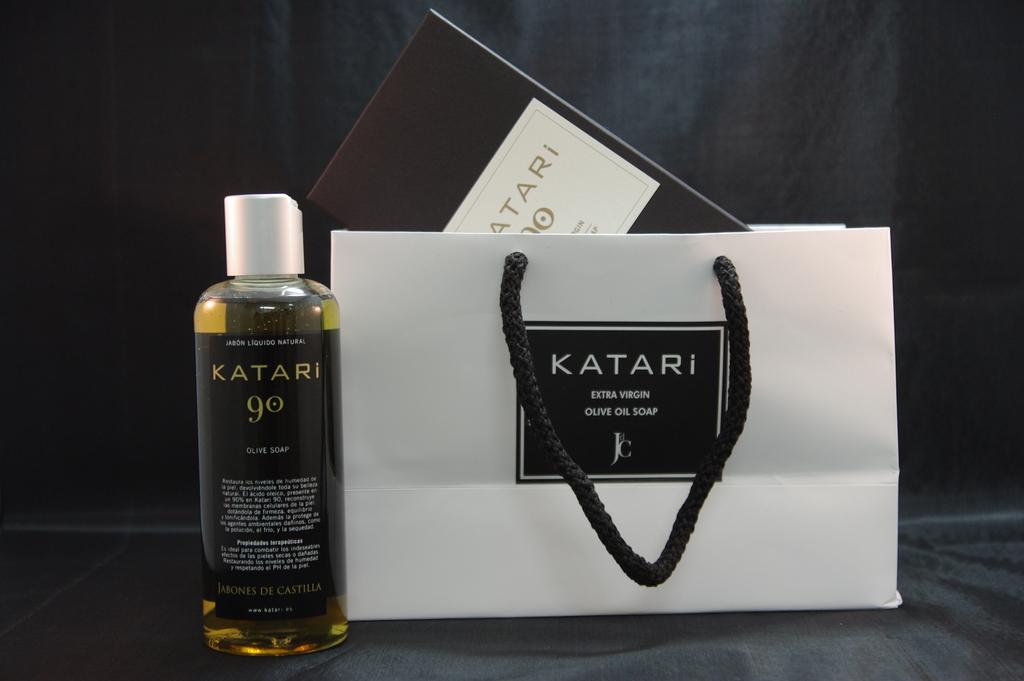What is this soap made from?
Your answer should be compact. Extra virgin olive oil. 